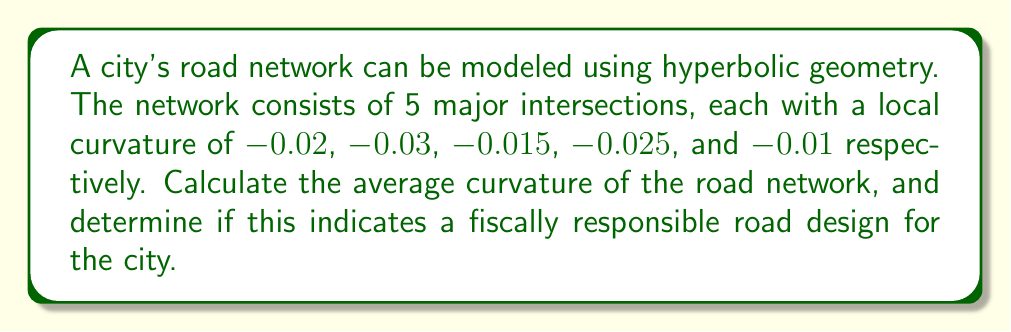Provide a solution to this math problem. To calculate the average curvature of the city's road network using hyperbolic geometry, we'll follow these steps:

1. List the given curvatures:
   $K_1 = -0.02$
   $K_2 = -0.03$
   $K_3 = -0.015$
   $K_4 = -0.025$
   $K_5 = -0.01$

2. Calculate the sum of the curvatures:
   $$\sum_{i=1}^{5} K_i = (-0.02) + (-0.03) + (-0.015) + (-0.025) + (-0.01) = -0.1$$

3. Calculate the average curvature by dividing the sum by the number of intersections:
   $$K_{avg} = \frac{\sum_{i=1}^{5} K_i}{5} = \frac{-0.1}{5} = -0.02$$

4. Interpret the result:
   In hyperbolic geometry, negative curvature indicates that the space curves away from itself. An average curvature of $-0.02$ suggests a moderate level of negative curvature in the road network.

5. Assess fiscal responsibility:
   A moderately negative curvature can be considered fiscally responsible for the following reasons:
   a) It allows for efficient use of space, potentially reducing land acquisition costs.
   b) The curvature is not too extreme, which could lead to increased construction and maintenance costs.
   c) It provides a balance between straight roads (which may encourage speeding) and overly curved roads (which may increase travel times and fuel consumption).

Therefore, this average curvature indicates a fiscally responsible road design for the city.
Answer: $-0.02$; fiscally responsible design 